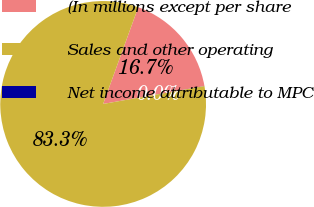Convert chart to OTSL. <chart><loc_0><loc_0><loc_500><loc_500><pie_chart><fcel>(In millions except per share<fcel>Sales and other operating<fcel>Net income attributable to MPC<nl><fcel>16.67%<fcel>83.32%<fcel>0.01%<nl></chart> 